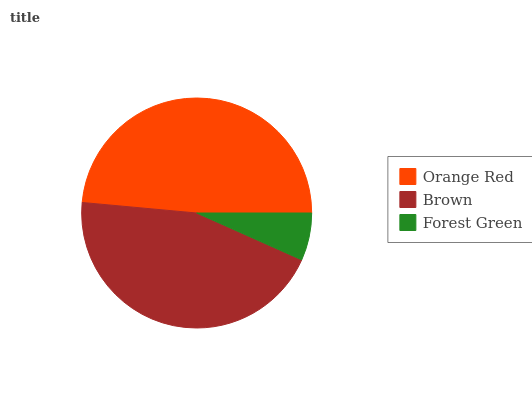Is Forest Green the minimum?
Answer yes or no. Yes. Is Orange Red the maximum?
Answer yes or no. Yes. Is Brown the minimum?
Answer yes or no. No. Is Brown the maximum?
Answer yes or no. No. Is Orange Red greater than Brown?
Answer yes or no. Yes. Is Brown less than Orange Red?
Answer yes or no. Yes. Is Brown greater than Orange Red?
Answer yes or no. No. Is Orange Red less than Brown?
Answer yes or no. No. Is Brown the high median?
Answer yes or no. Yes. Is Brown the low median?
Answer yes or no. Yes. Is Orange Red the high median?
Answer yes or no. No. Is Forest Green the low median?
Answer yes or no. No. 